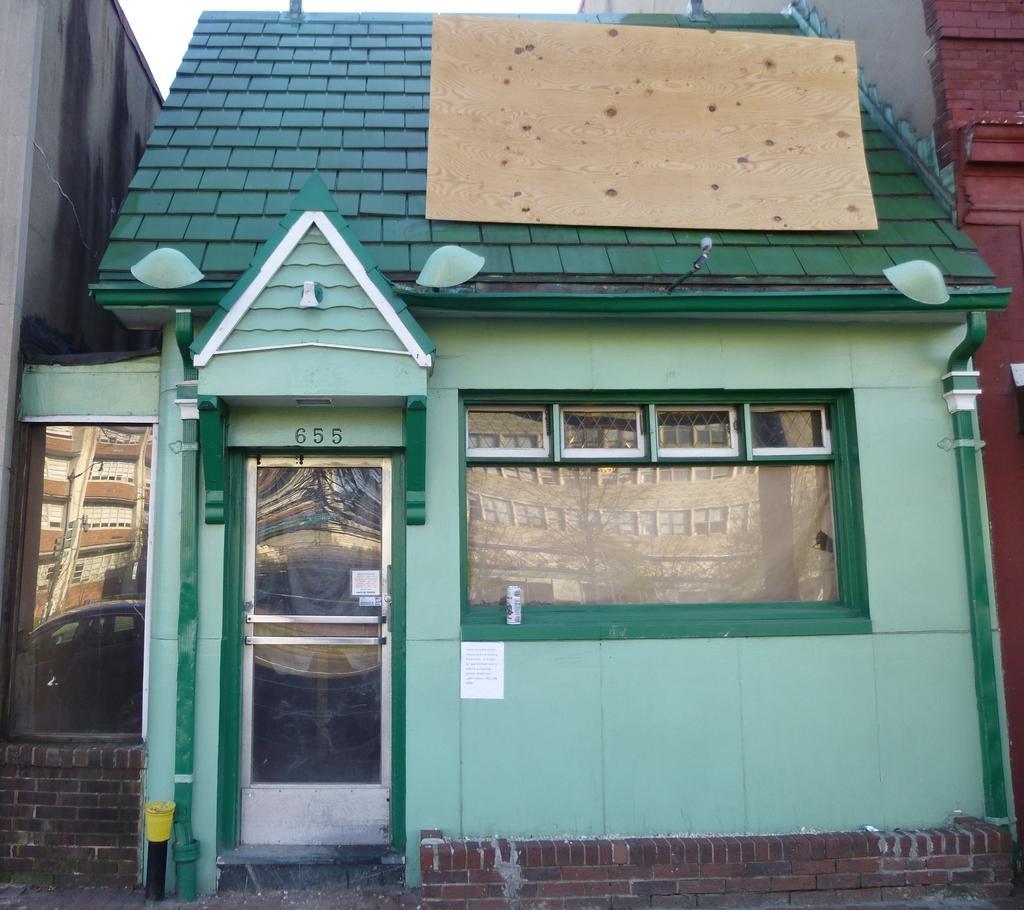How would you summarize this image in a sentence or two? In this image, we can see small house, there is a glass door and we can see some windows, at the top there is a sky. 